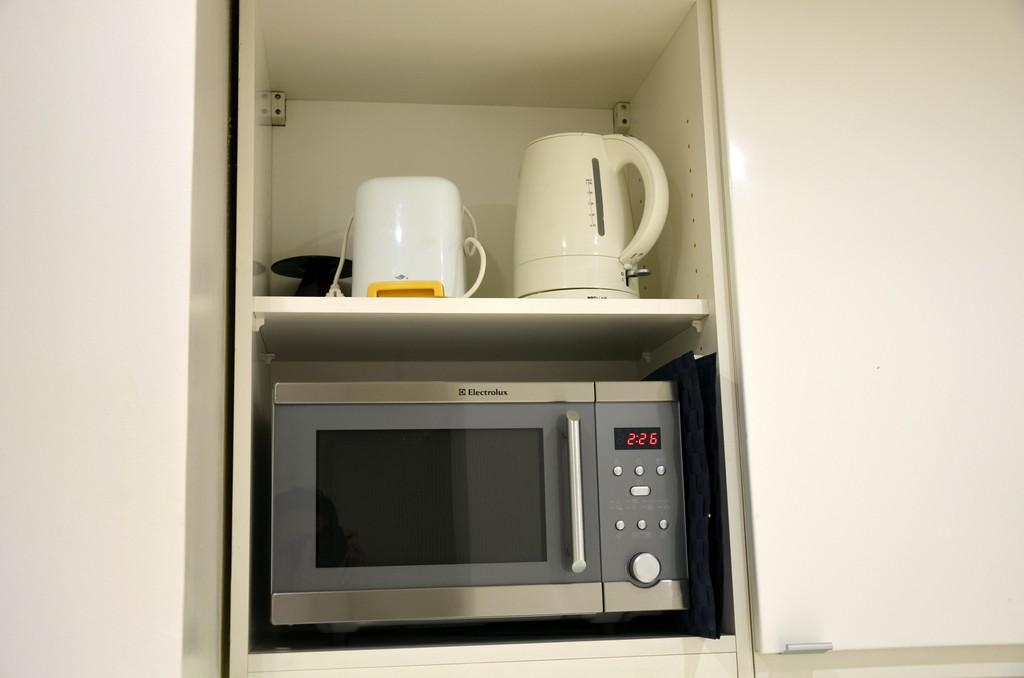<image>
Summarize the visual content of the image. a microwave oven that says '2:26' on it 